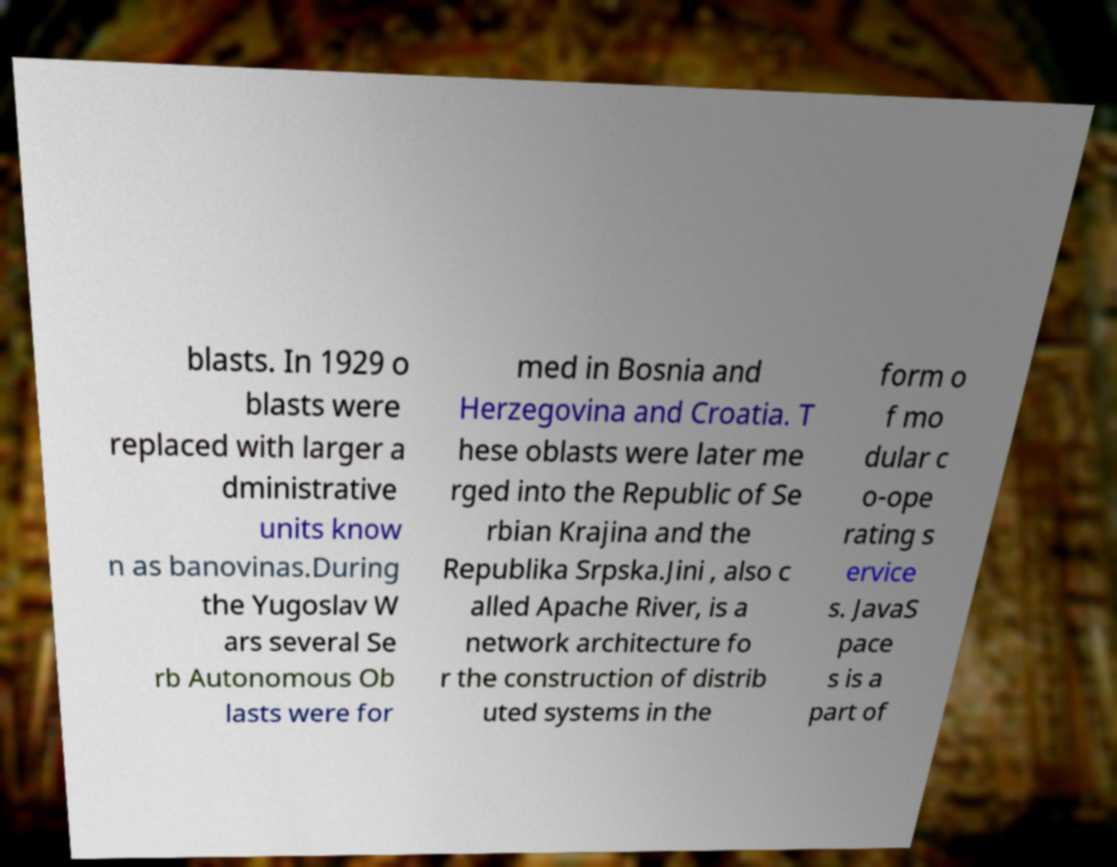I need the written content from this picture converted into text. Can you do that? blasts. In 1929 o blasts were replaced with larger a dministrative units know n as banovinas.During the Yugoslav W ars several Se rb Autonomous Ob lasts were for med in Bosnia and Herzegovina and Croatia. T hese oblasts were later me rged into the Republic of Se rbian Krajina and the Republika Srpska.Jini , also c alled Apache River, is a network architecture fo r the construction of distrib uted systems in the form o f mo dular c o-ope rating s ervice s. JavaS pace s is a part of 